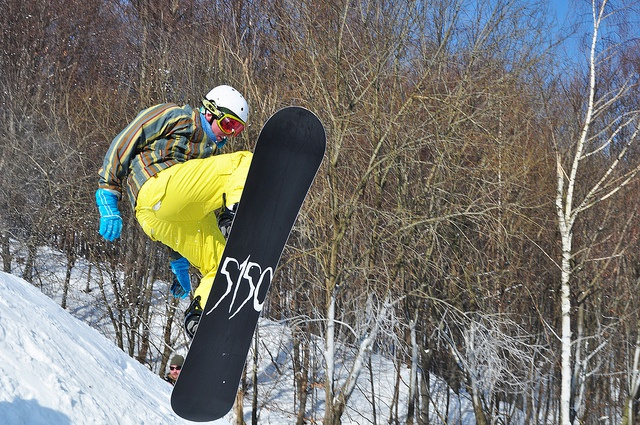Describe the objects in this image and their specific colors. I can see people in black, yellow, khaki, and gold tones, snowboard in black, white, and gray tones, and people in black, gray, lightpink, and brown tones in this image. 